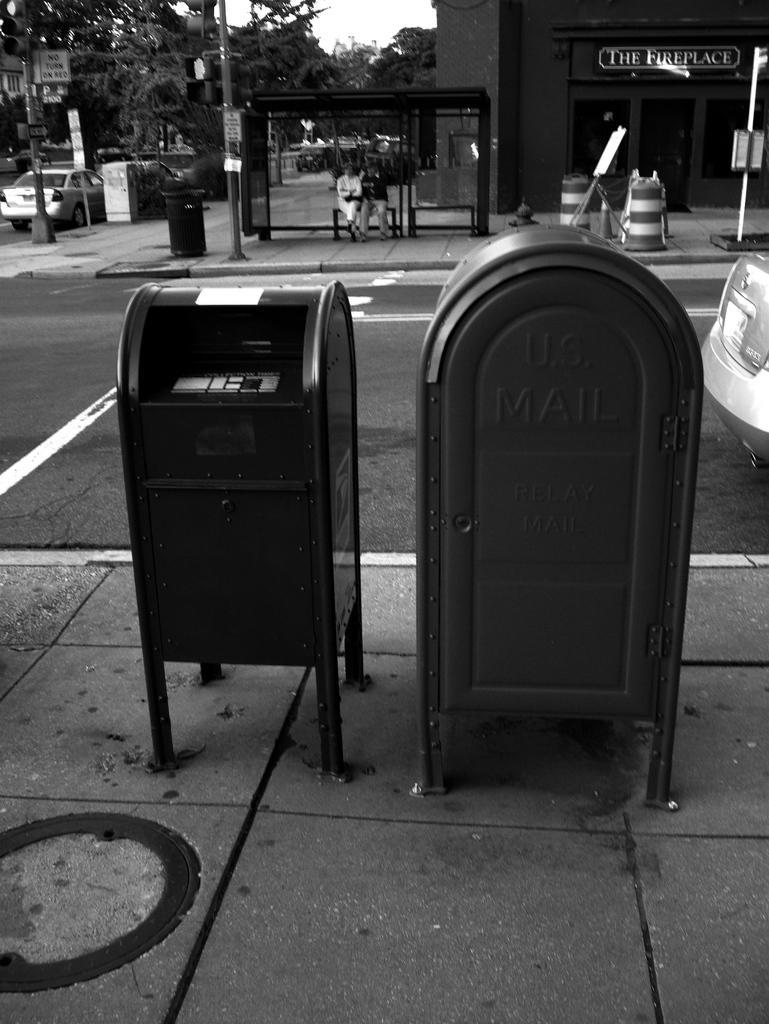How would you summarize this image in a sentence or two? In this picture there are mail boxes in the center of the image, there are cars on the right and left side of the image, there are people, trees, poles and buildings in the background area of the image. 